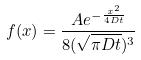Convert formula to latex. <formula><loc_0><loc_0><loc_500><loc_500>f ( x ) = \frac { A e ^ { - \frac { x ^ { 2 } } { 4 D t } } } { 8 ( \sqrt { \pi D t } ) ^ { 3 } }</formula> 